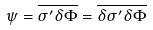<formula> <loc_0><loc_0><loc_500><loc_500>\psi = \overline { \sigma ^ { \prime } \delta \Phi } = \overline { \delta \sigma ^ { \prime } \delta \Phi }</formula> 